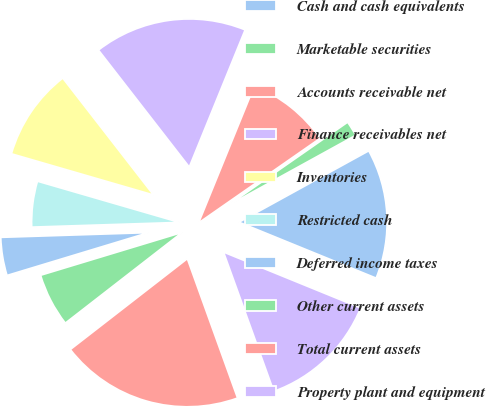Convert chart to OTSL. <chart><loc_0><loc_0><loc_500><loc_500><pie_chart><fcel>Cash and cash equivalents<fcel>Marketable securities<fcel>Accounts receivable net<fcel>Finance receivables net<fcel>Inventories<fcel>Restricted cash<fcel>Deferred income taxes<fcel>Other current assets<fcel>Total current assets<fcel>Property plant and equipment<nl><fcel>14.17%<fcel>1.67%<fcel>9.17%<fcel>16.66%<fcel>10.0%<fcel>5.0%<fcel>4.17%<fcel>5.83%<fcel>20.0%<fcel>13.33%<nl></chart> 